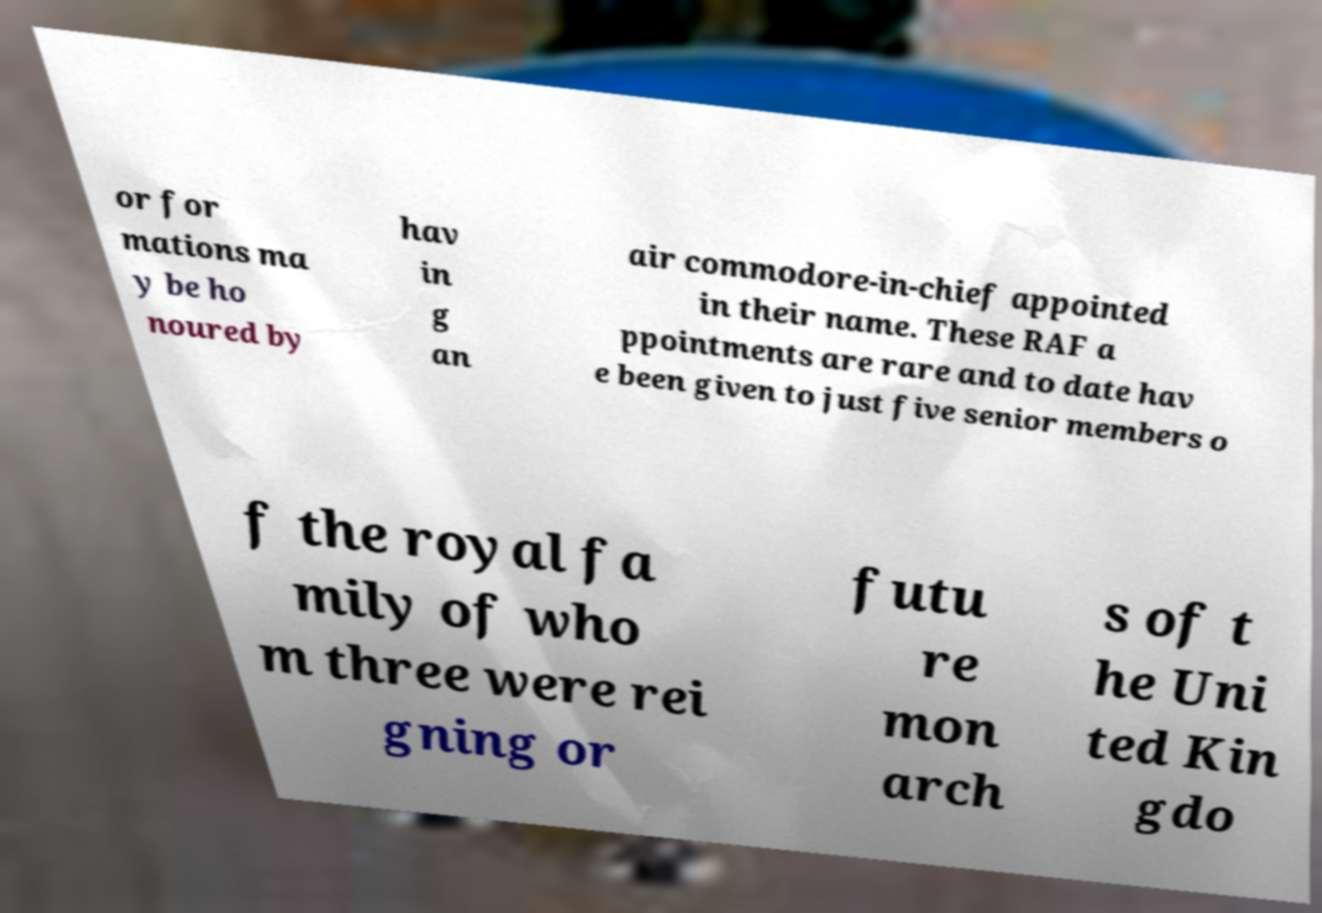What messages or text are displayed in this image? I need them in a readable, typed format. or for mations ma y be ho noured by hav in g an air commodore-in-chief appointed in their name. These RAF a ppointments are rare and to date hav e been given to just five senior members o f the royal fa mily of who m three were rei gning or futu re mon arch s of t he Uni ted Kin gdo 